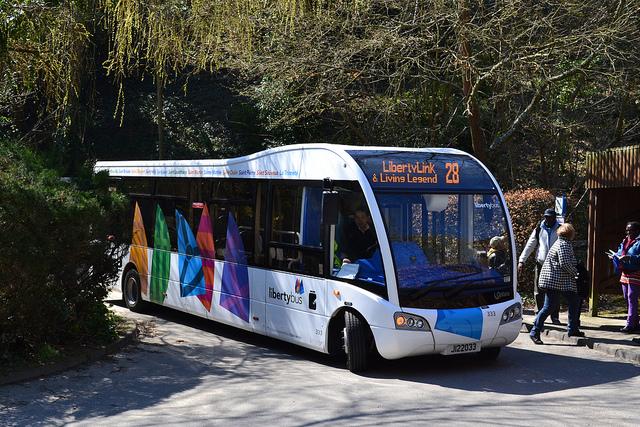Is the bus in motion?
Concise answer only. Yes. What is the bus company?
Short answer required. Liberty bus. Are the people getting ready to board the bus?
Give a very brief answer. No. What is the bus number?
Be succinct. 28. 